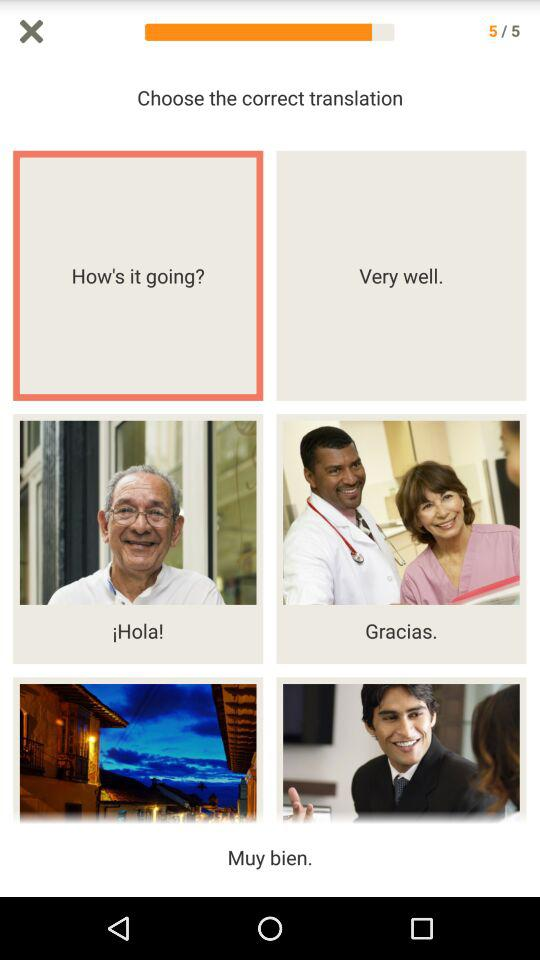On what page am I at? You are on page number 5. 